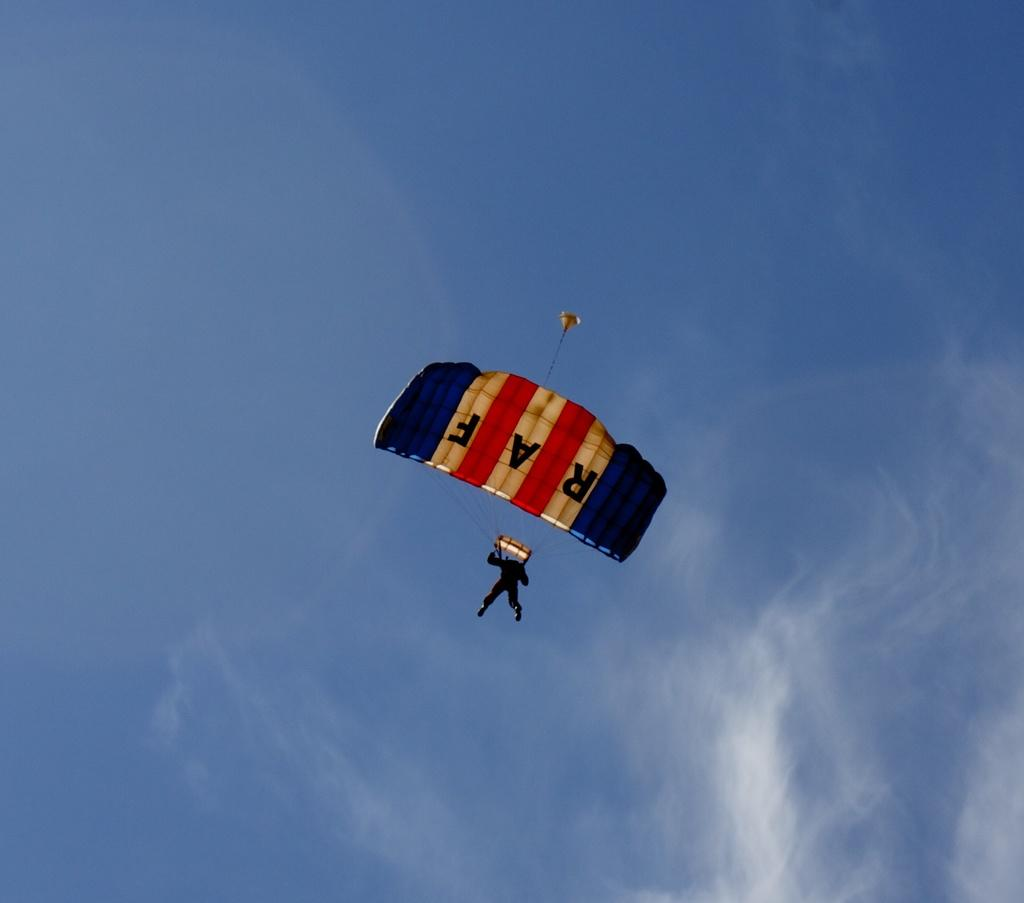<image>
Give a short and clear explanation of the subsequent image. A red white and blue parachute with the letters RAF 